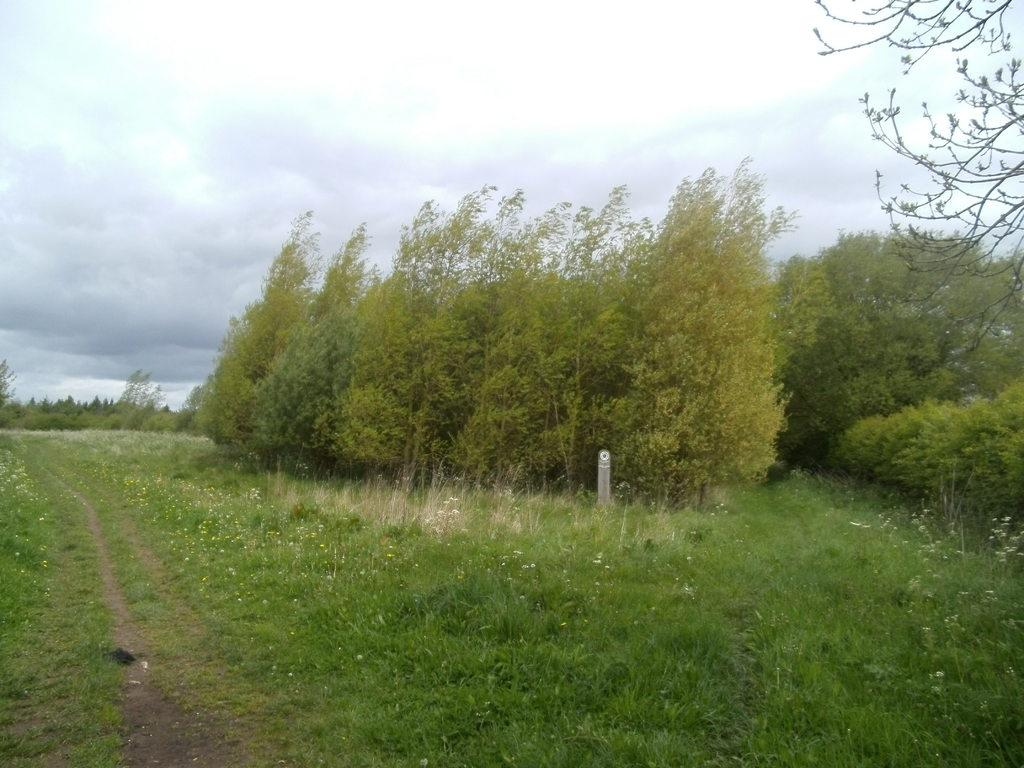What type of surface covers the area in the image? The area in the image is covered with grass. Are there any plants or vegetation in the image? Yes, trees are present in the image. What is the condition of the sky in the image? The sky is cloudy in the image. What color is the ink on the elbow in the image? There is no ink or elbow present in the image; it features grass, trees, and a cloudy sky. 